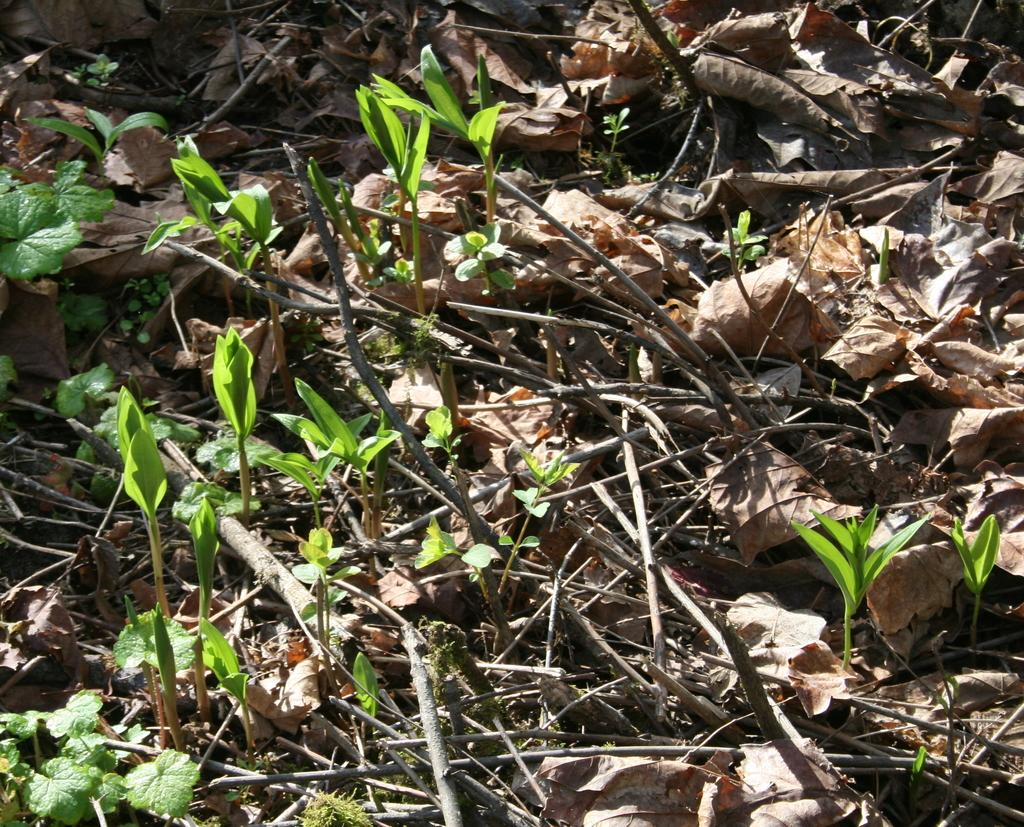What type of living organisms can be seen in the image? Plants and small plants are visible in the image. What other natural elements can be seen in the image? Twigs and dry leaves are present in the image. What is the base material for the plants and small plants? Soil is visible in the image. What type of weather can be seen in the image? The image does not depict weather; it shows plants, twigs, dry leaves, and soil. Is there any sand visible in the image? No, there is no sand present in the image. 